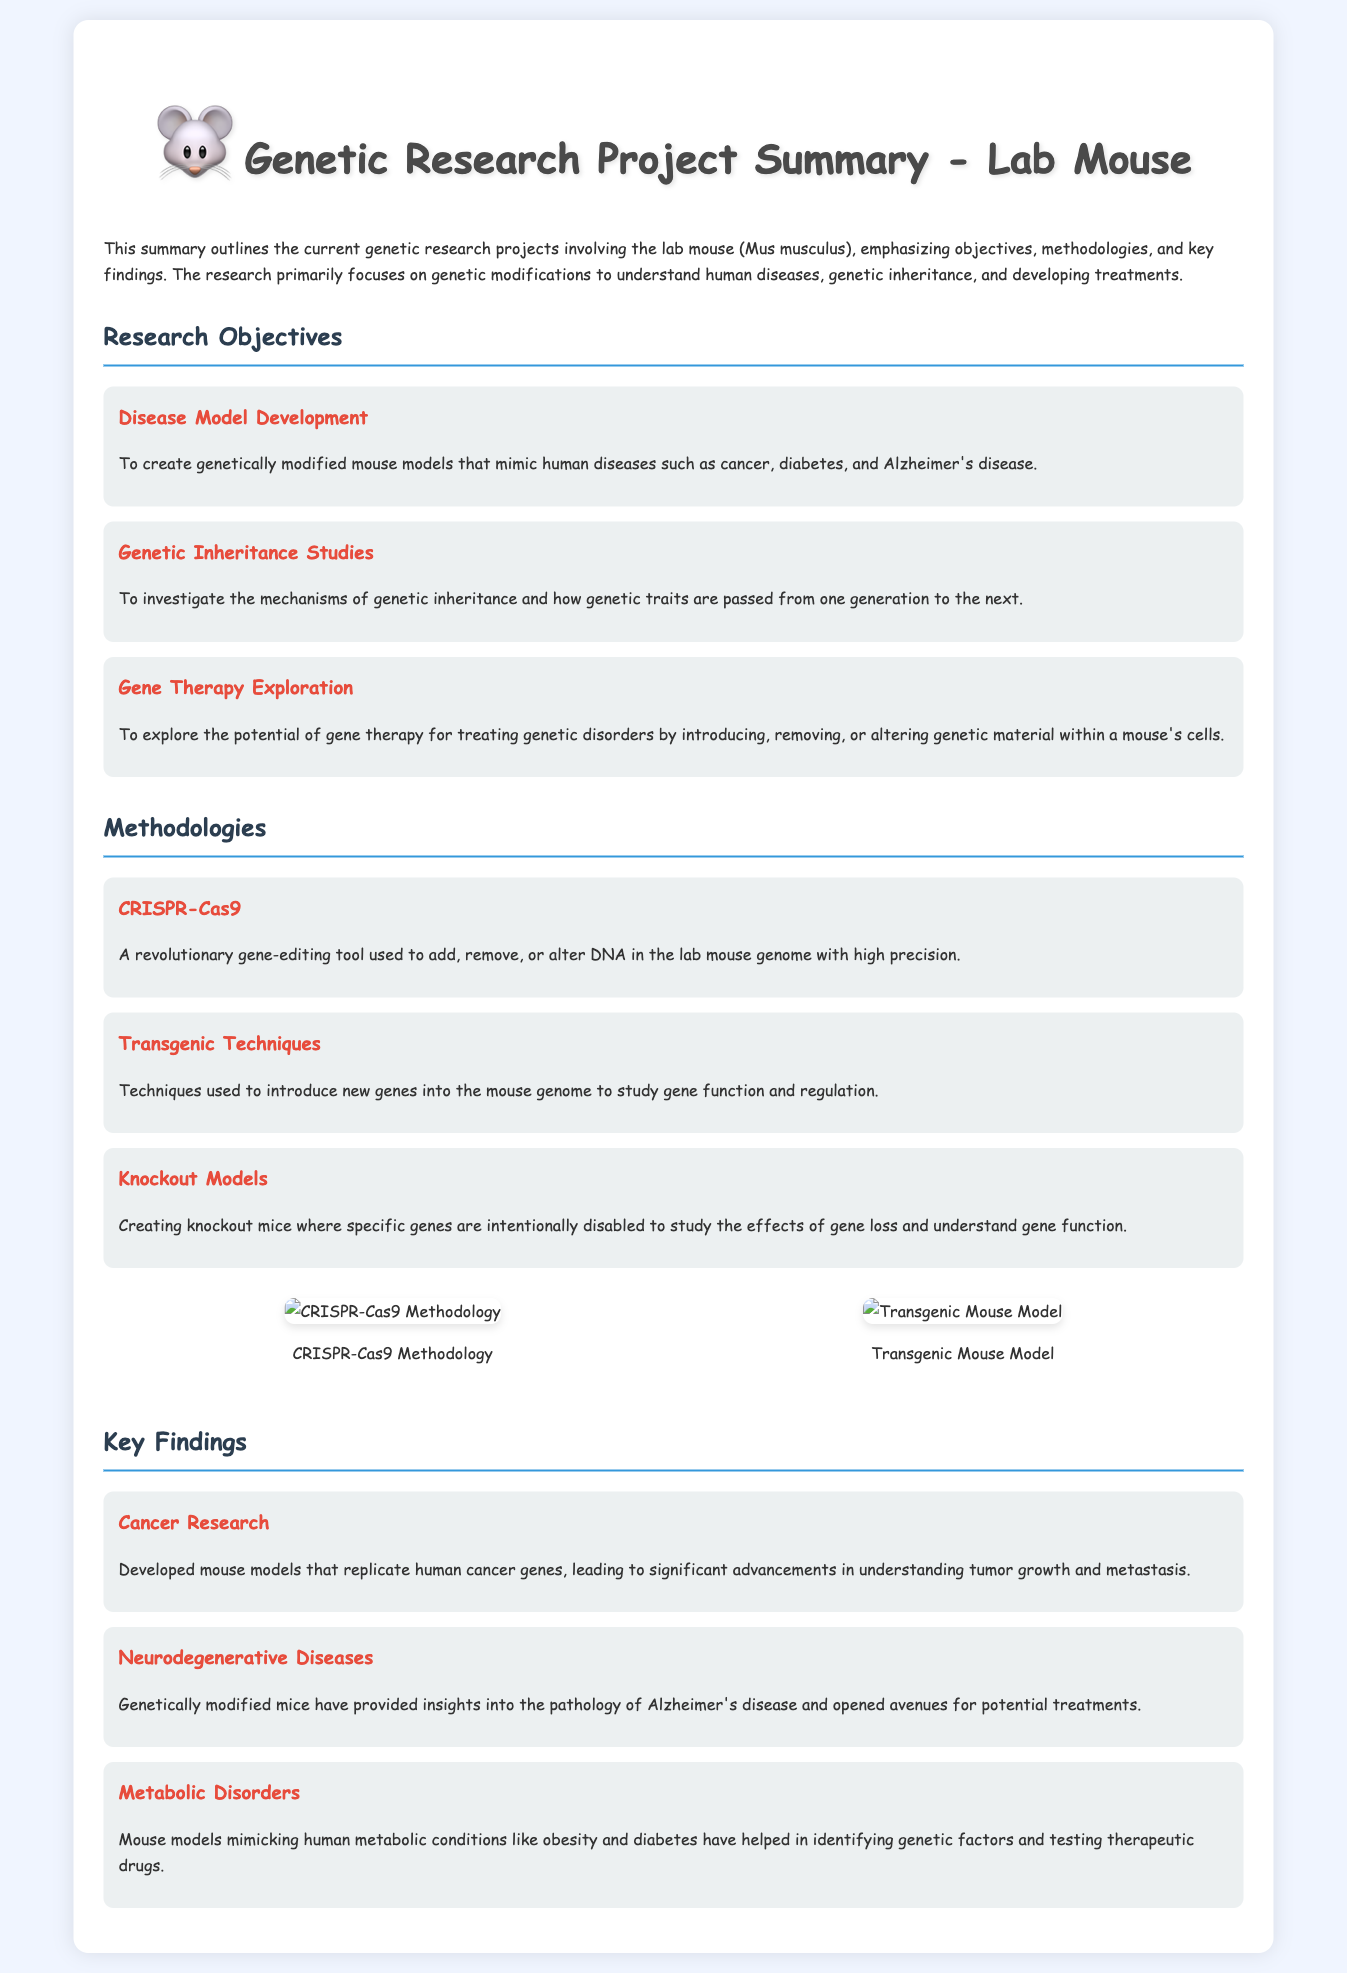What are the three main research objectives? The document outlines three objectives in genetic research related to the lab mouse: Disease Model Development, Genetic Inheritance Studies, and Gene Therapy Exploration.
Answer: Disease Model Development, Genetic Inheritance Studies, Gene Therapy Exploration What gene-editing tool is mentioned? The document states that CRISPR-Cas9 is a revolutionary gene-editing tool used in the research projects.
Answer: CRISPR-Cas9 Which disease is studied with modified mice? The document highlights that genetically modified mice have provided insights into the pathology of Alzheimer's disease.
Answer: Alzheimer's disease What is a technique used for introducing new genes? The document mentions transgenic techniques as a method used to introduce new genes into the mouse genome.
Answer: Transgenic Techniques How many key findings are listed in the document? The document lists three key findings related to genetic research outcomes from the lab mouse studies.
Answer: Three What methodology is used for creating knockout mice? The document describes knockout models as a methodology used to intentionally disable specific genes in mice.
Answer: Knockout Models What has the cancer research led to? The document states that cancer research developed mouse models that replicate human cancer genes, leading to advancements in understanding tumor growth.
Answer: Advancements in understanding tumor growth What is depicted in the first diagram? The first diagram related to CRISPR-Cas9 methodology is mentioned in the document.
Answer: CRISPR-Cas9 Methodology 